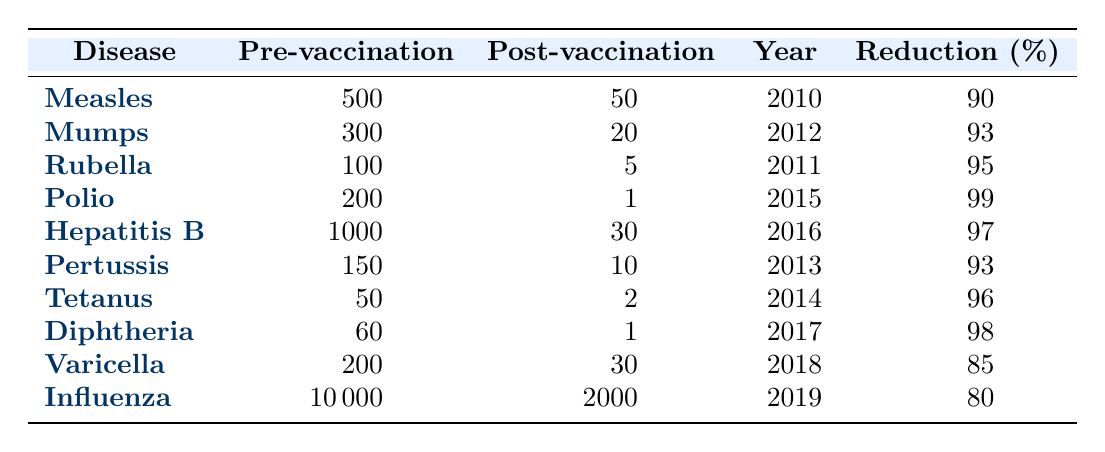What was the incidence rate of Measles pre-vaccination? The incidence rate for Measles is listed under the "Pre-vaccination" column, which shows a value of 500.
Answer: 500 What is the reduction percentage for Pertussis? The reduction percentage for Pertussis is found in the "Reduction (%)" column, which shows a value of 93.
Answer: 93% Which disease had the highest pre-vaccination incidence rate? By comparing the "Pre-vaccination" column values, the highest rate is 10000 for Influenza.
Answer: Influenza What is the average incidence rate post-vaccination for all diseases listed? To find the average, sum the "Post-vaccination" values (50 + 20 + 5 + 1 + 30 + 10 + 2 + 1 + 30 + 2000 = 2150) and divide by the number of diseases (10), resulting in 215.
Answer: 215 Did the incidence rate of Polio drop below 5 post-vaccination? The "Post-vaccination" rate for Polio is 1, which is below 5.
Answer: Yes What was the incidence rate for Diphtheria, and how much did it reduce by after vaccination? Diphtheria had a pre-vaccination rate of 60 and a post-vaccination rate of 1, leading to a reduction of 59.
Answer: 59 Which disease had the second highest reduction percentage? By comparing the "Reduction (%)" values, Mumps had the second highest at 93% after Polio.
Answer: Mumps What is the total incidence rate reduction for all diseases combined post-vaccination? First, sum the pre-vaccination rates (500 + 300 + 100 + 200 + 1000 + 150 + 50 + 60 + 200 + 10000 = 11610) and then the post-vaccination rates (50 + 20 + 5 + 1 + 30 + 10 + 2 + 1 + 30 + 2000 = 2150). The total reduction is 11610 - 2150 = 9450.
Answer: 9450 Was the incidence rate of Rubella higher or lower than Mumps pre-vaccination? Rubella's pre-vaccination rate is 100, while Mumps' is 300; therefore, Rubella is lower.
Answer: Lower What is the percentage reduction for Varicella? The reduction percentage for Varicella is calculated as ((200 - 30) / 200) * 100 = 85.
Answer: 85% 